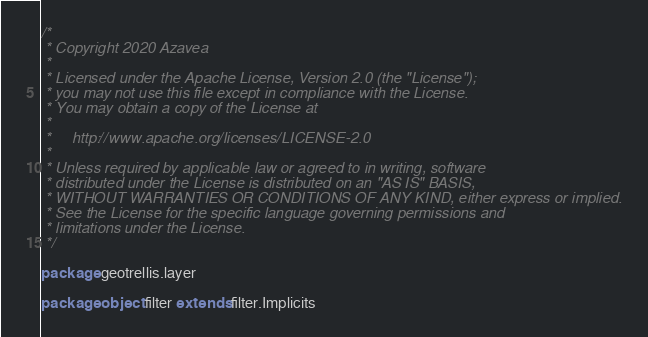Convert code to text. <code><loc_0><loc_0><loc_500><loc_500><_Scala_>/*
 * Copyright 2020 Azavea
 *
 * Licensed under the Apache License, Version 2.0 (the "License");
 * you may not use this file except in compliance with the License.
 * You may obtain a copy of the License at
 *
 *     http://www.apache.org/licenses/LICENSE-2.0
 *
 * Unless required by applicable law or agreed to in writing, software
 * distributed under the License is distributed on an "AS IS" BASIS,
 * WITHOUT WARRANTIES OR CONDITIONS OF ANY KIND, either express or implied.
 * See the License for the specific language governing permissions and
 * limitations under the License.
 */

package geotrellis.layer

package object filter extends filter.Implicits
</code> 